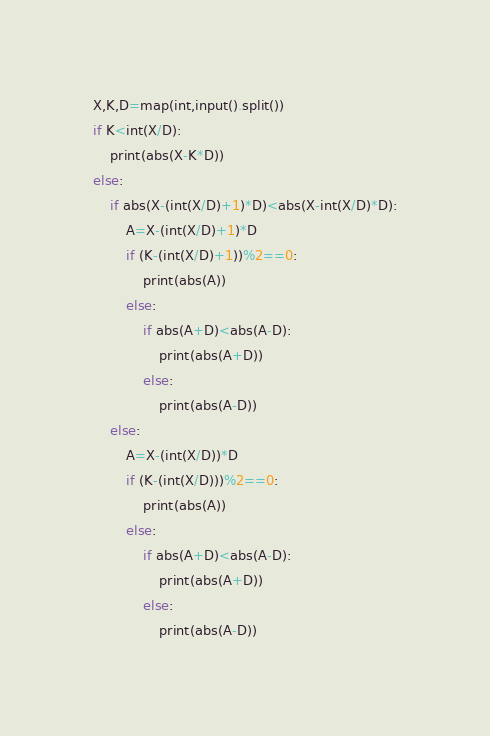Convert code to text. <code><loc_0><loc_0><loc_500><loc_500><_Python_>X,K,D=map(int,input().split())
if K<int(X/D):
    print(abs(X-K*D))
else:
    if abs(X-(int(X/D)+1)*D)<abs(X-int(X/D)*D):
        A=X-(int(X/D)+1)*D
        if (K-(int(X/D)+1))%2==0:
            print(abs(A))
        else:
            if abs(A+D)<abs(A-D):
                print(abs(A+D))
            else:
                print(abs(A-D))
    else:
        A=X-(int(X/D))*D
        if (K-(int(X/D)))%2==0:
            print(abs(A))
        else:
            if abs(A+D)<abs(A-D):
                print(abs(A+D))
            else:
                print(abs(A-D))</code> 